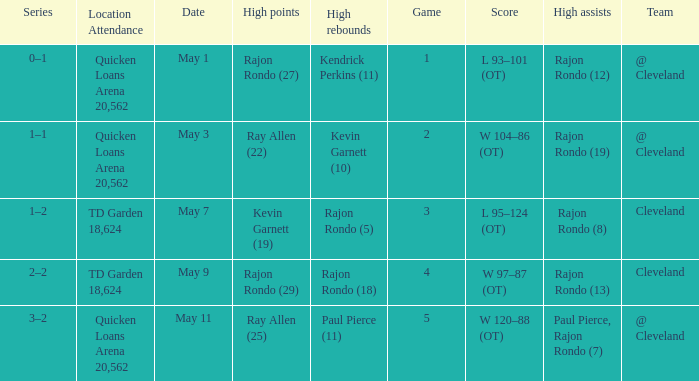Where does the team play May 3? @ Cleveland. 